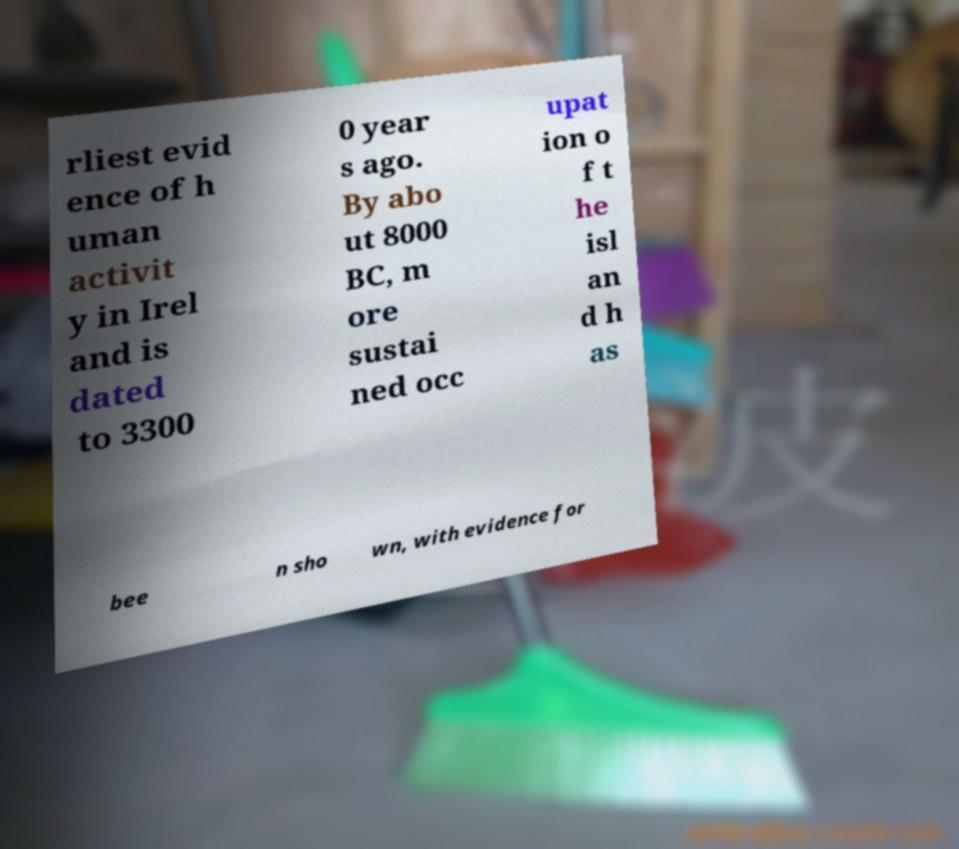For documentation purposes, I need the text within this image transcribed. Could you provide that? rliest evid ence of h uman activit y in Irel and is dated to 3300 0 year s ago. By abo ut 8000 BC, m ore sustai ned occ upat ion o f t he isl an d h as bee n sho wn, with evidence for 